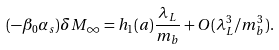<formula> <loc_0><loc_0><loc_500><loc_500>( - \beta _ { 0 } \alpha _ { s } ) \delta M _ { \infty } = h _ { 1 } ( a ) \frac { \lambda _ { L } } { m _ { b } } + O ( \lambda _ { L } ^ { 3 } / m _ { b } ^ { 3 } ) .</formula> 